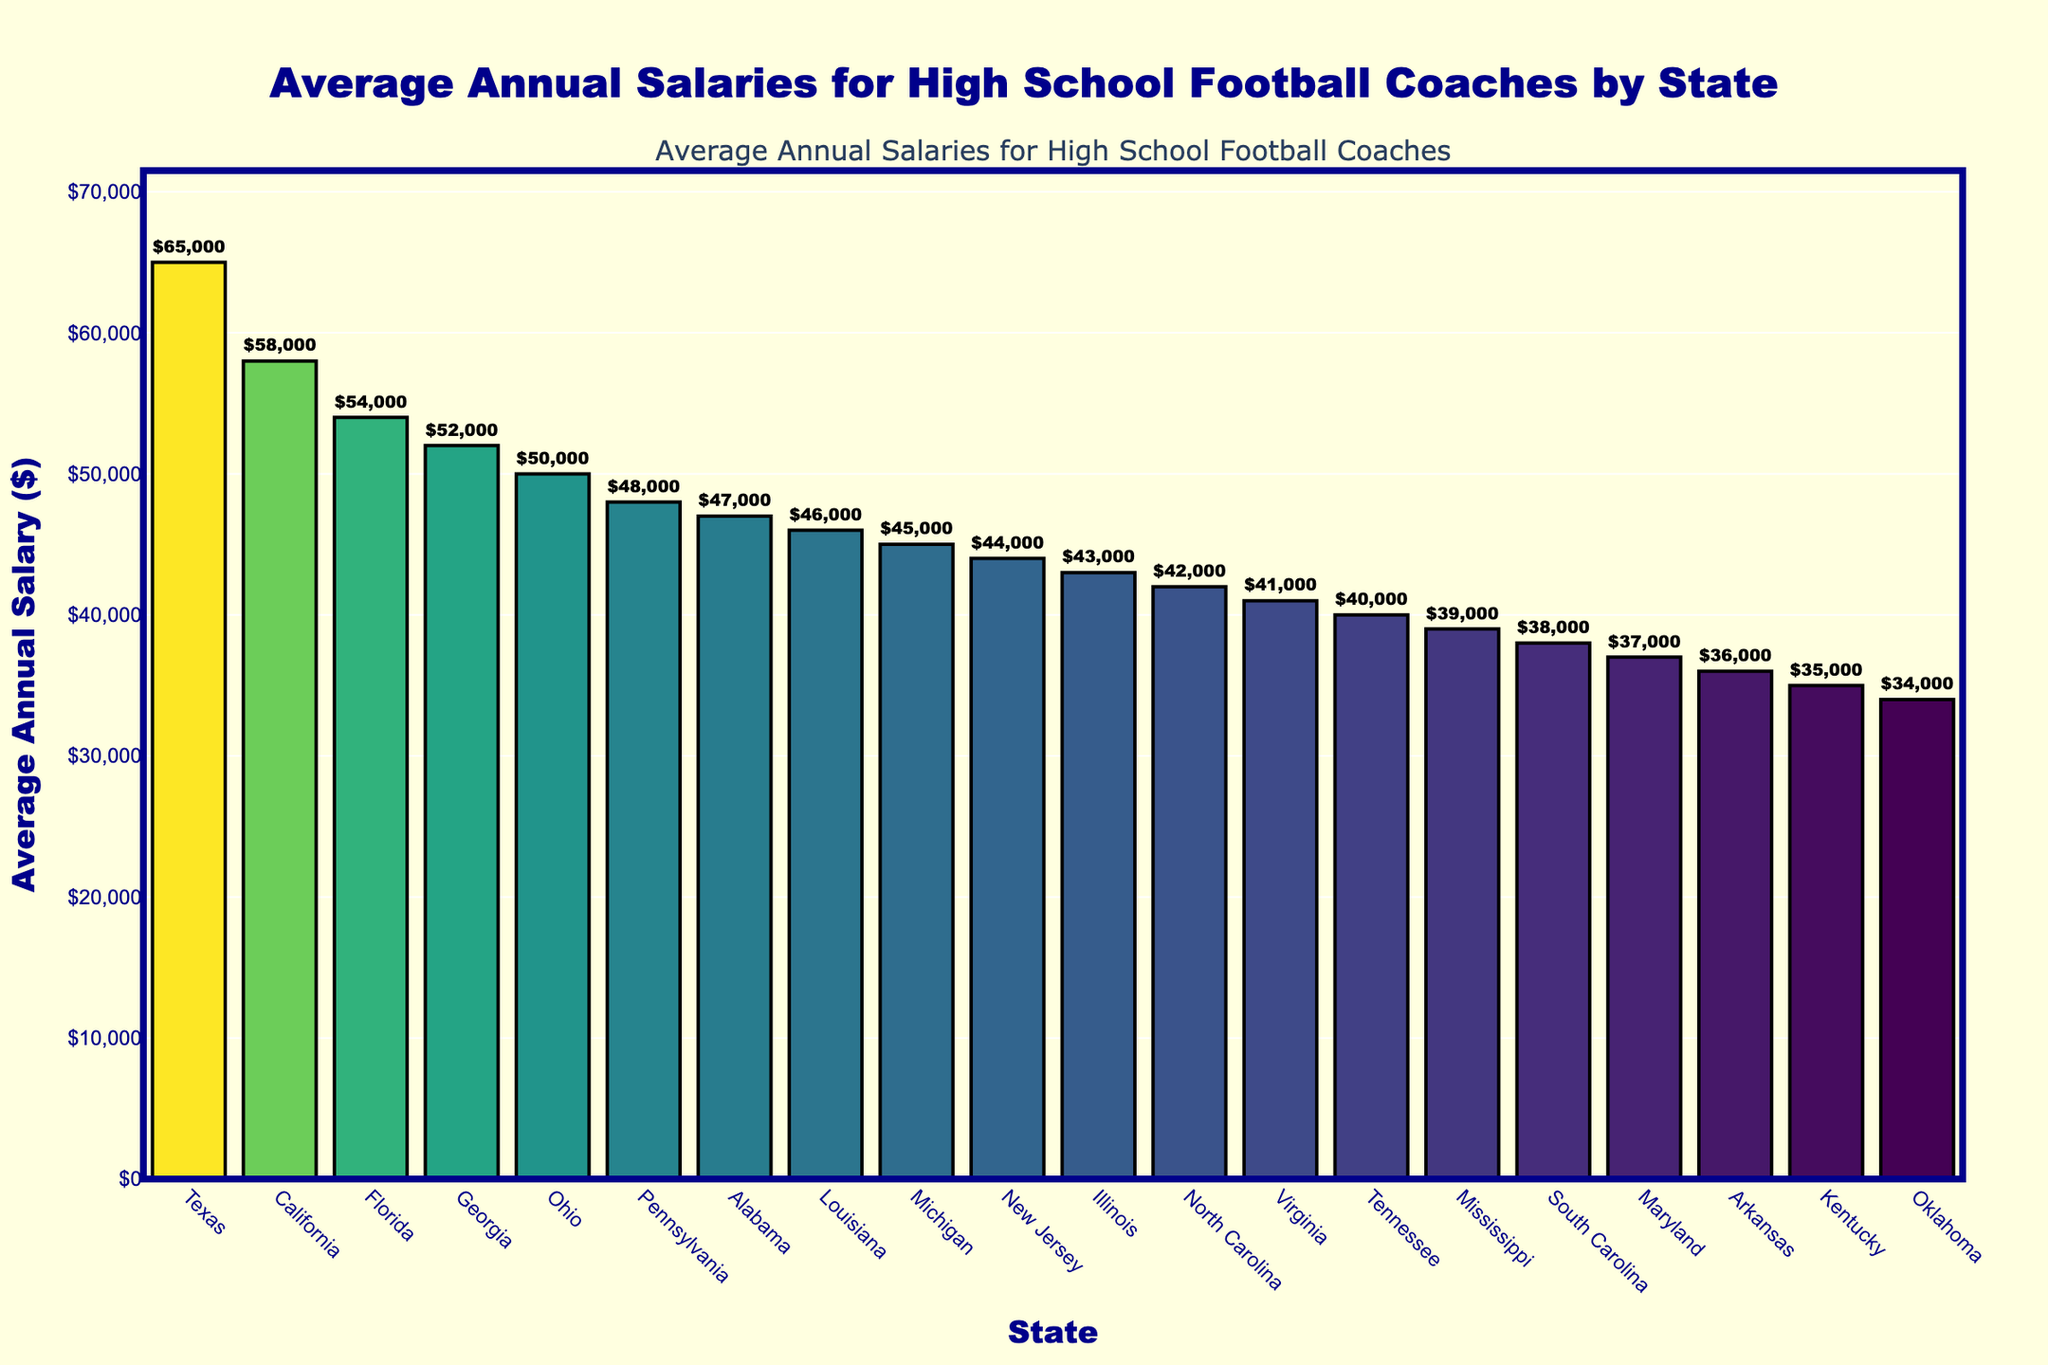Which state has the highest average salary for high school football coaches? The bar representing Texas is the tallest, indicating that Texas has the highest average salary.
Answer: Texas What is the difference in average salary between the highest and the lowest paid states? The highest average salary is $65,000 (Texas) and the lowest is $34,000 (Oklahoma). The difference is $65,000 - $34,000 = $31,000.
Answer: $31,000 How does the average salary in California compare to Florida? California has an average salary of $58,000 and Florida has $54,000. California's average salary is higher by $58,000 - $54,000 = $4,000.
Answer: $4,000 higher Which states have an average salary greater than $50,000? By examining the figure, the states with bars reaching above the $50,000 mark are Texas, California, Florida, and Georgia.
Answer: Texas, California, Florida, Georgia What is the median average salary for the states shown? To find the median, list all the salaries in order and find the middle value. Sorting the salaries: $34,000, $35,000, $36,000, $37,000, $38,000, $39,000, $40,000, $41,000, $42,000, $43,000, $44,000, $45,000, $46,000, $47,000, $48,000, $50,000, $52,000, $54,000, $58,000, $65,000. The median value (middle of the list) is $43,000.
Answer: $43,000 How many states have an average salary below $40,000? The states with bars lower than the $40,000 mark are Mississippi, South Carolina, Maryland, Arkansas, Kentucky, and Oklahoma, making it 6 states.
Answer: 6 What's the combined total of the average salaries for Texas, California, and Florida? Summing the values: Texas ($65,000) + California ($58,000) + Florida ($54,000) = $65,000 + $58,000 + $54,000 = $177,000.
Answer: $177,000 Which state has the closest average salary to $45,000? By visually comparing the bar heights, Michigan has an average salary closest to $45,000.
Answer: Michigan Are there more states with an average salary above or below $50,000? Counting the bars: states above $50,000 (4 states: Texas, California, Florida, Georgia) and below $50,000 (16 states), so there are more states below $50,000.
Answer: More states below $50,000 